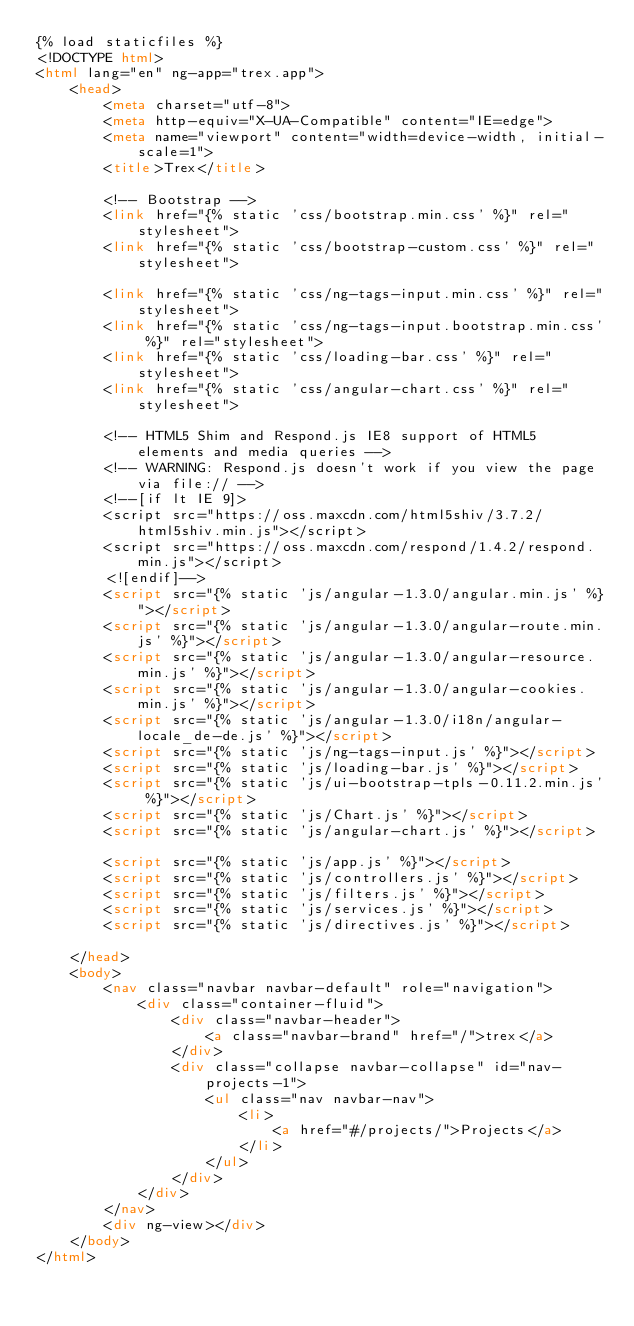Convert code to text. <code><loc_0><loc_0><loc_500><loc_500><_HTML_>{% load staticfiles %}
<!DOCTYPE html>
<html lang="en" ng-app="trex.app">
    <head>
        <meta charset="utf-8">
        <meta http-equiv="X-UA-Compatible" content="IE=edge">
        <meta name="viewport" content="width=device-width, initial-scale=1">
        <title>Trex</title>

        <!-- Bootstrap -->
        <link href="{% static 'css/bootstrap.min.css' %}" rel="stylesheet">
        <link href="{% static 'css/bootstrap-custom.css' %}" rel="stylesheet">

        <link href="{% static 'css/ng-tags-input.min.css' %}" rel="stylesheet">
        <link href="{% static 'css/ng-tags-input.bootstrap.min.css' %}" rel="stylesheet">
        <link href="{% static 'css/loading-bar.css' %}" rel="stylesheet">
        <link href="{% static 'css/angular-chart.css' %}" rel="stylesheet">

        <!-- HTML5 Shim and Respond.js IE8 support of HTML5 elements and media queries -->
        <!-- WARNING: Respond.js doesn't work if you view the page via file:// -->
        <!--[if lt IE 9]>
        <script src="https://oss.maxcdn.com/html5shiv/3.7.2/html5shiv.min.js"></script>
        <script src="https://oss.maxcdn.com/respond/1.4.2/respond.min.js"></script>
        <![endif]-->
        <script src="{% static 'js/angular-1.3.0/angular.min.js' %}"></script>
        <script src="{% static 'js/angular-1.3.0/angular-route.min.js' %}"></script>
        <script src="{% static 'js/angular-1.3.0/angular-resource.min.js' %}"></script>
        <script src="{% static 'js/angular-1.3.0/angular-cookies.min.js' %}"></script>
        <script src="{% static 'js/angular-1.3.0/i18n/angular-locale_de-de.js' %}"></script>
        <script src="{% static 'js/ng-tags-input.js' %}"></script>
        <script src="{% static 'js/loading-bar.js' %}"></script>
        <script src="{% static 'js/ui-bootstrap-tpls-0.11.2.min.js' %}"></script>
        <script src="{% static 'js/Chart.js' %}"></script>
        <script src="{% static 'js/angular-chart.js' %}"></script>

        <script src="{% static 'js/app.js' %}"></script>
        <script src="{% static 'js/controllers.js' %}"></script>
        <script src="{% static 'js/filters.js' %}"></script>
        <script src="{% static 'js/services.js' %}"></script>
        <script src="{% static 'js/directives.js' %}"></script>

    </head>
    <body>
        <nav class="navbar navbar-default" role="navigation">
            <div class="container-fluid">
                <div class="navbar-header">
                    <a class="navbar-brand" href="/">trex</a>
                </div>
                <div class="collapse navbar-collapse" id="nav-projects-1">
                    <ul class="nav navbar-nav">
                        <li>
                            <a href="#/projects/">Projects</a>
                        </li>
                    </ul>
                </div>
            </div>
        </nav>
        <div ng-view></div>
    </body>
</html>
</code> 